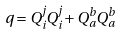Convert formula to latex. <formula><loc_0><loc_0><loc_500><loc_500>q = Q _ { i } ^ { j } Q _ { i } ^ { j } + Q _ { a } ^ { b } Q _ { a } ^ { b }</formula> 